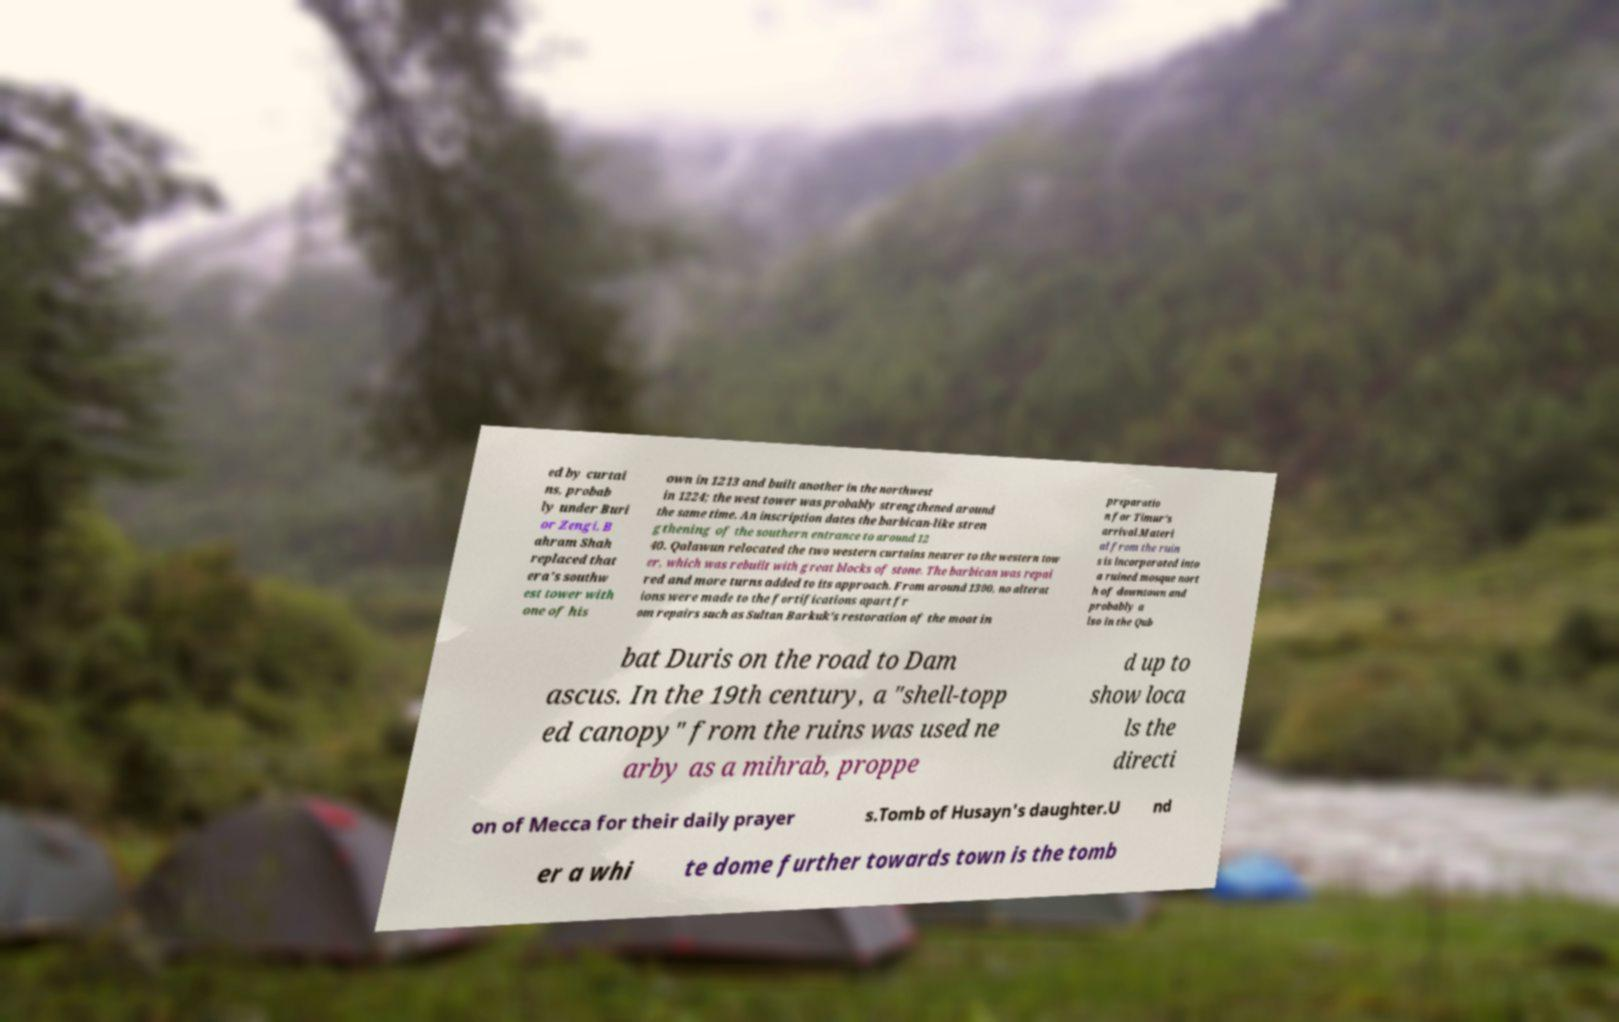Could you extract and type out the text from this image? ed by curtai ns, probab ly under Buri or Zengi. B ahram Shah replaced that era's southw est tower with one of his own in 1213 and built another in the northwest in 1224; the west tower was probably strengthened around the same time. An inscription dates the barbican-like stren gthening of the southern entrance to around 12 40. Qalawun relocated the two western curtains nearer to the western tow er, which was rebuilt with great blocks of stone. The barbican was repai red and more turns added to its approach. From around 1300, no alterat ions were made to the fortifications apart fr om repairs such as Sultan Barkuk's restoration of the moat in preparatio n for Timur's arrival.Materi al from the ruin s is incorporated into a ruined mosque nort h of downtown and probably a lso in the Qub bat Duris on the road to Dam ascus. In the 19th century, a "shell-topp ed canopy" from the ruins was used ne arby as a mihrab, proppe d up to show loca ls the directi on of Mecca for their daily prayer s.Tomb of Husayn's daughter.U nd er a whi te dome further towards town is the tomb 